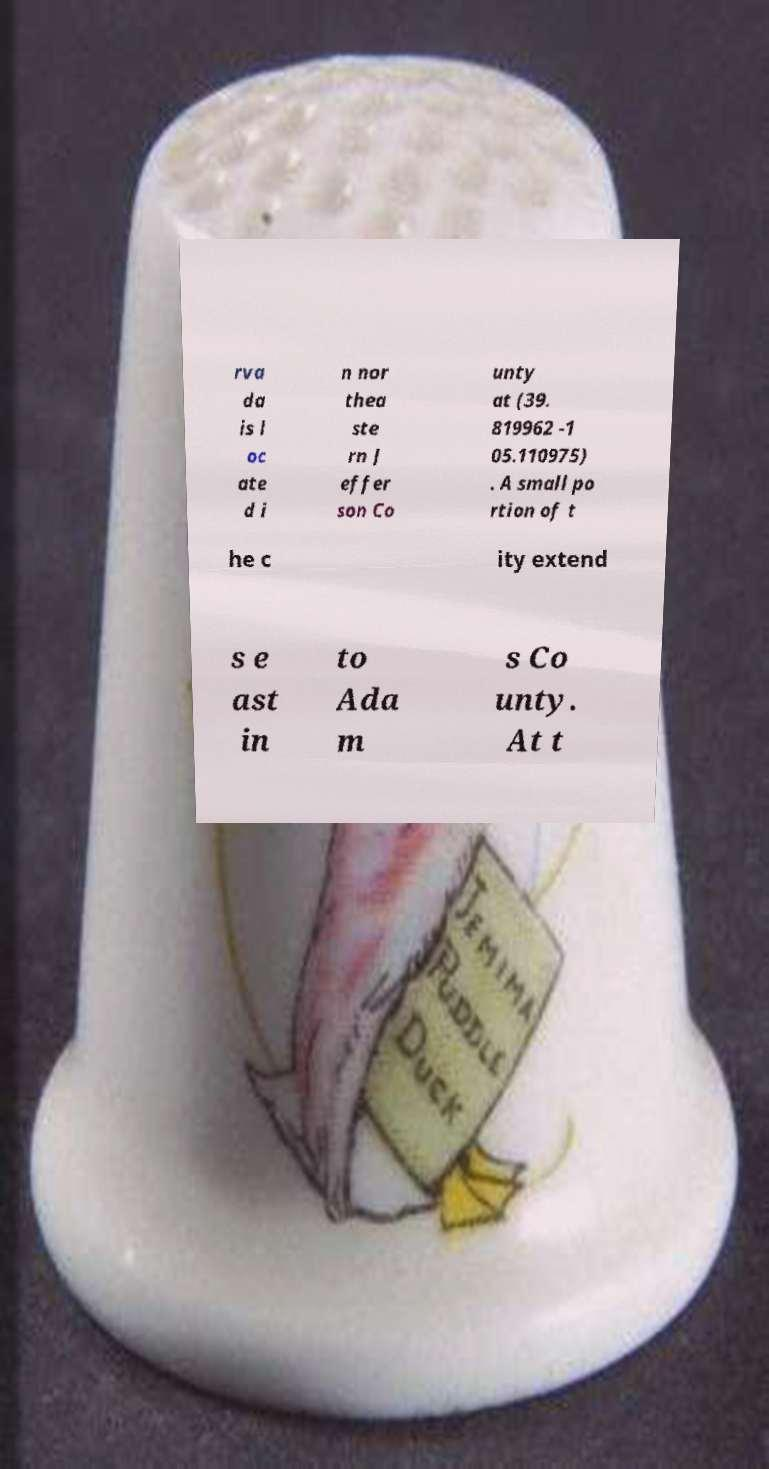What messages or text are displayed in this image? I need them in a readable, typed format. rva da is l oc ate d i n nor thea ste rn J effer son Co unty at (39. 819962 -1 05.110975) . A small po rtion of t he c ity extend s e ast in to Ada m s Co unty. At t 